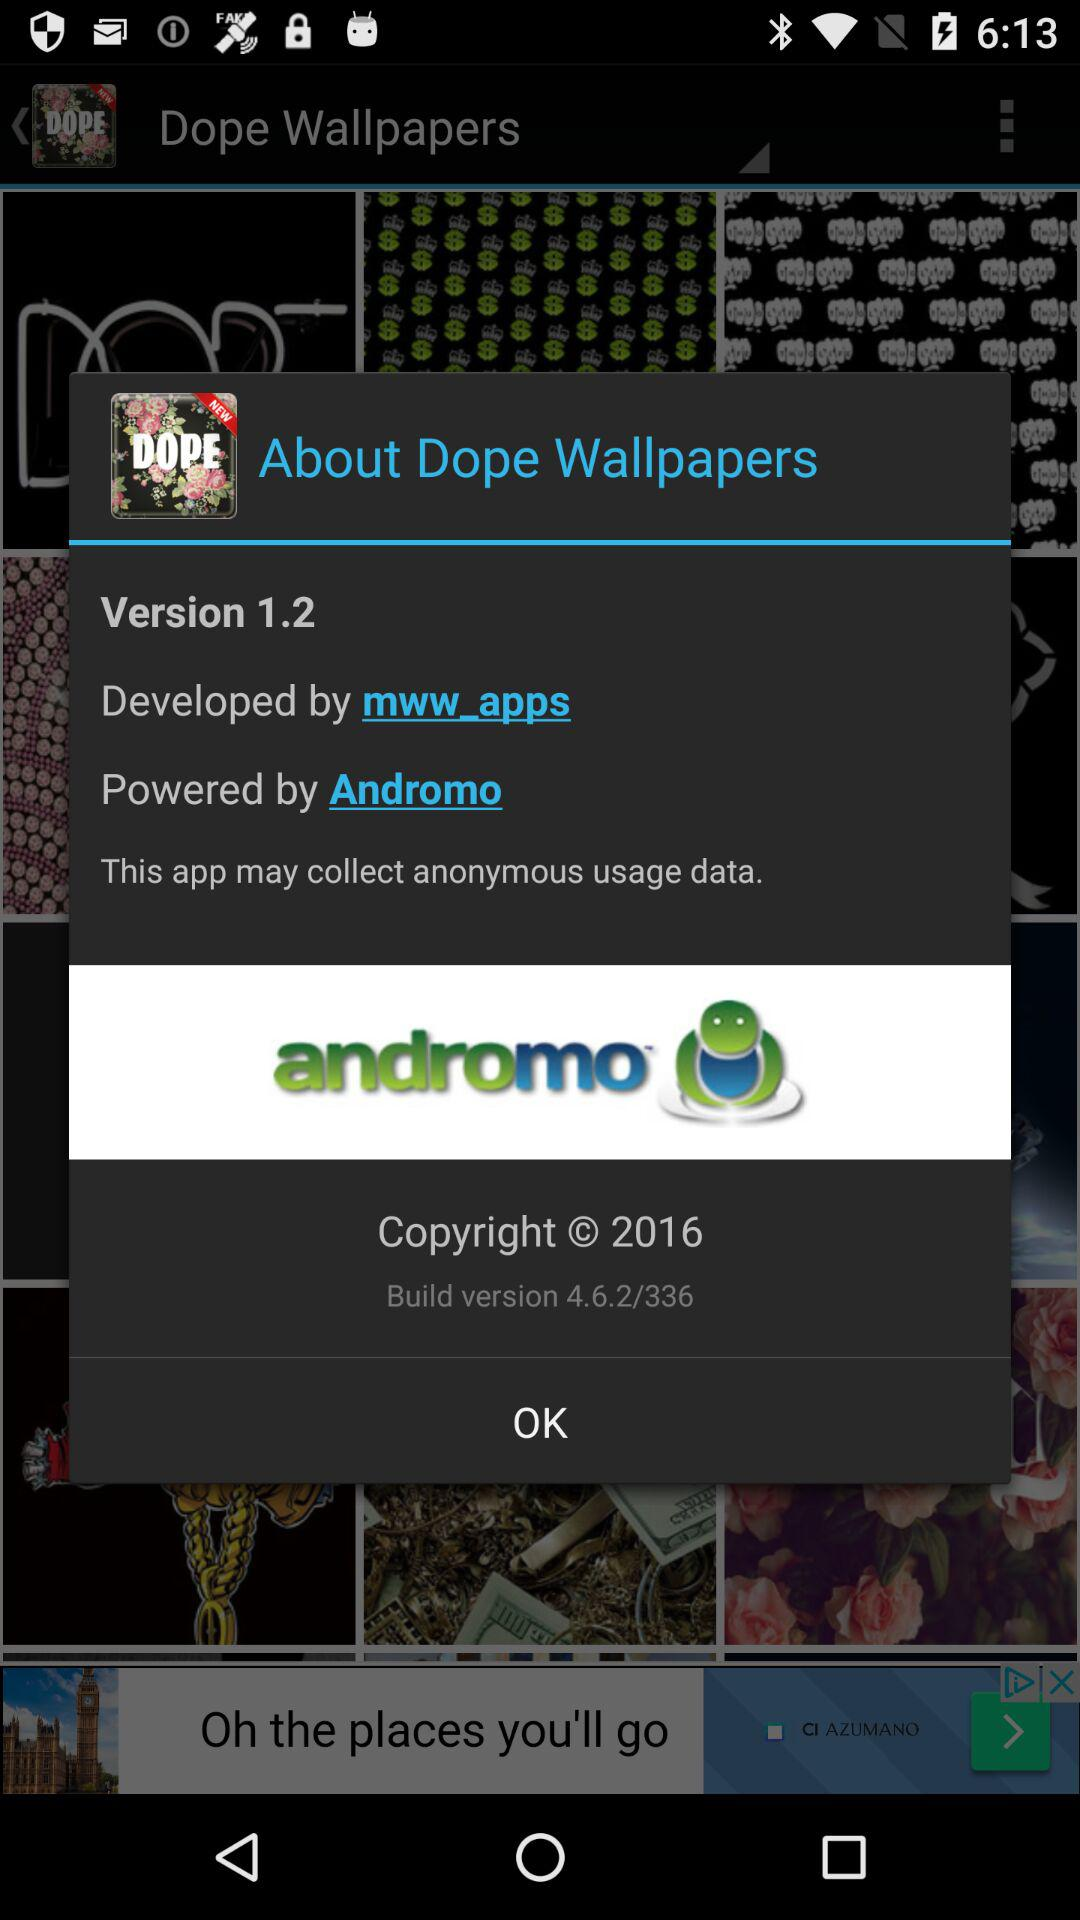What is the version of the application being used? The version of the application is 1.2. 